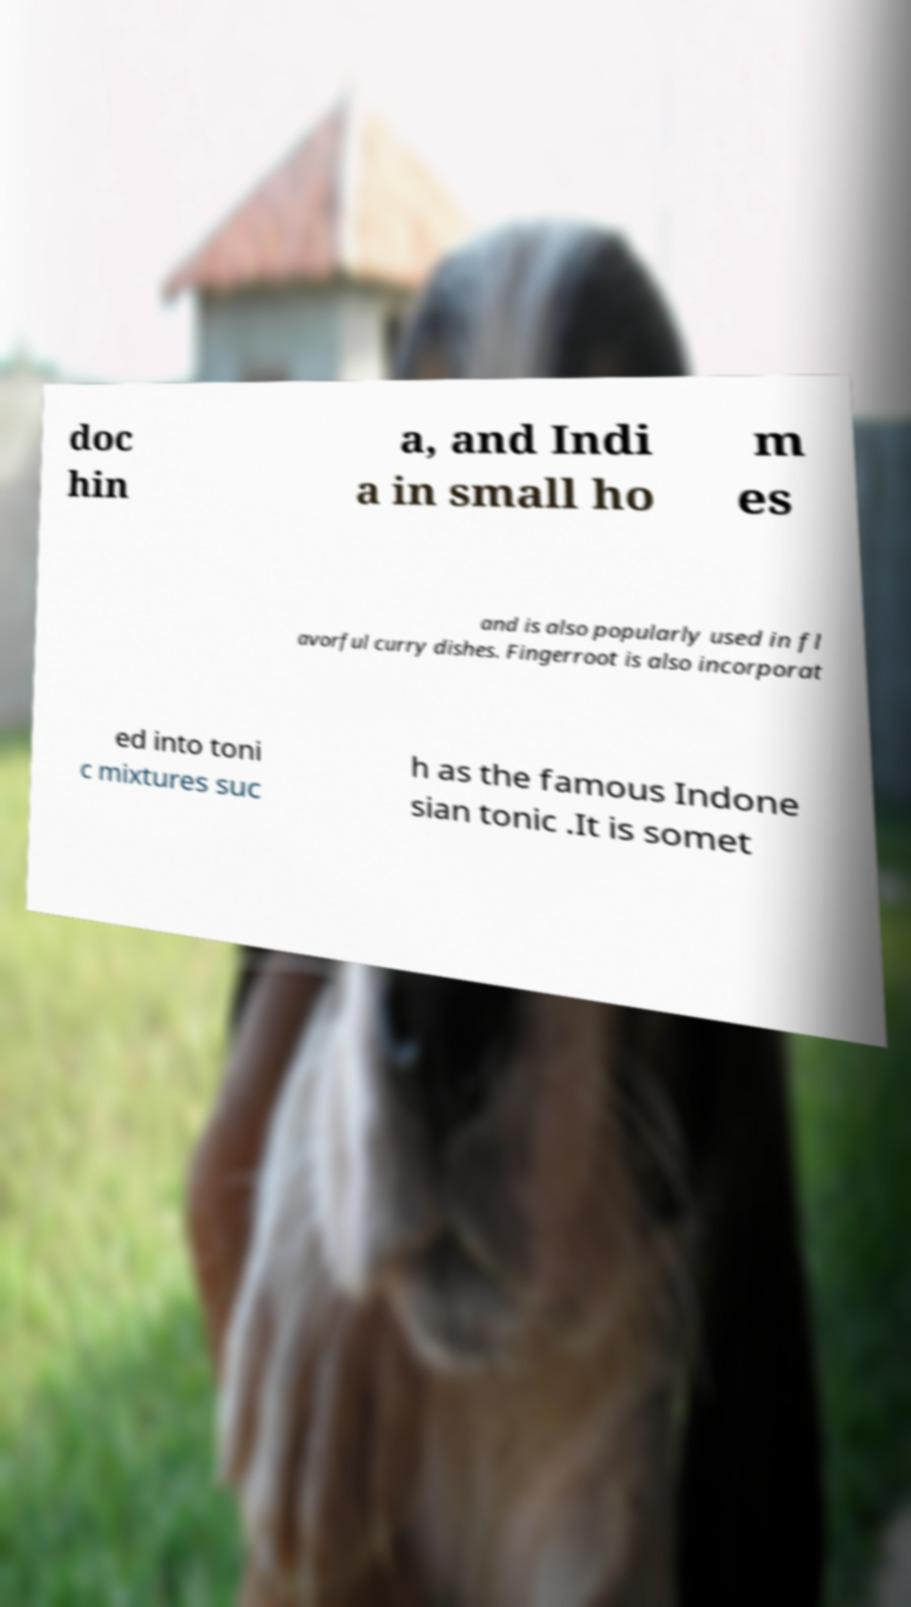Please read and relay the text visible in this image. What does it say? doc hin a, and Indi a in small ho m es and is also popularly used in fl avorful curry dishes. Fingerroot is also incorporat ed into toni c mixtures suc h as the famous Indone sian tonic .It is somet 